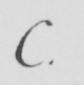What text is written in this handwritten line? C . 